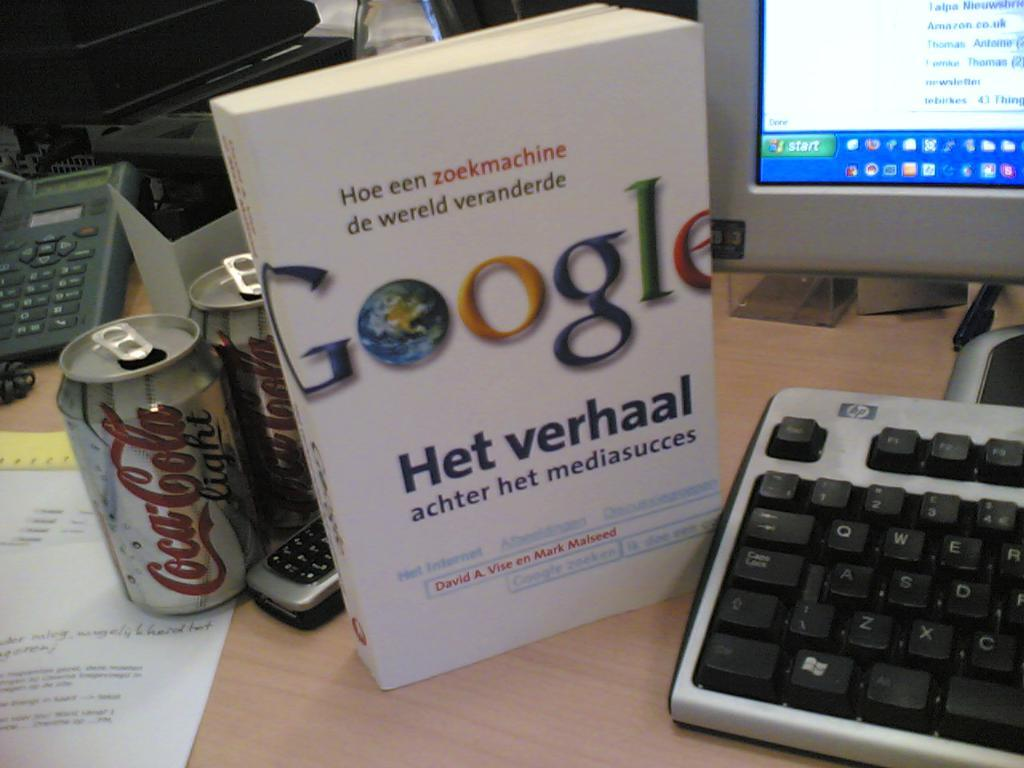Provide a one-sentence caption for the provided image. A computer with what appears to be a user manual for Google, but i do not know what it says. 